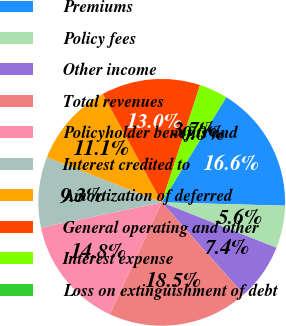Convert chart to OTSL. <chart><loc_0><loc_0><loc_500><loc_500><pie_chart><fcel>Premiums<fcel>Policy fees<fcel>Other income<fcel>Total revenues<fcel>Policyholder benefits and<fcel>Interest credited to<fcel>Amortization of deferred<fcel>General operating and other<fcel>Interest expense<fcel>Loss on extinguishment of debt<nl><fcel>16.65%<fcel>5.57%<fcel>7.41%<fcel>18.5%<fcel>14.8%<fcel>9.26%<fcel>11.11%<fcel>12.96%<fcel>3.72%<fcel>0.03%<nl></chart> 